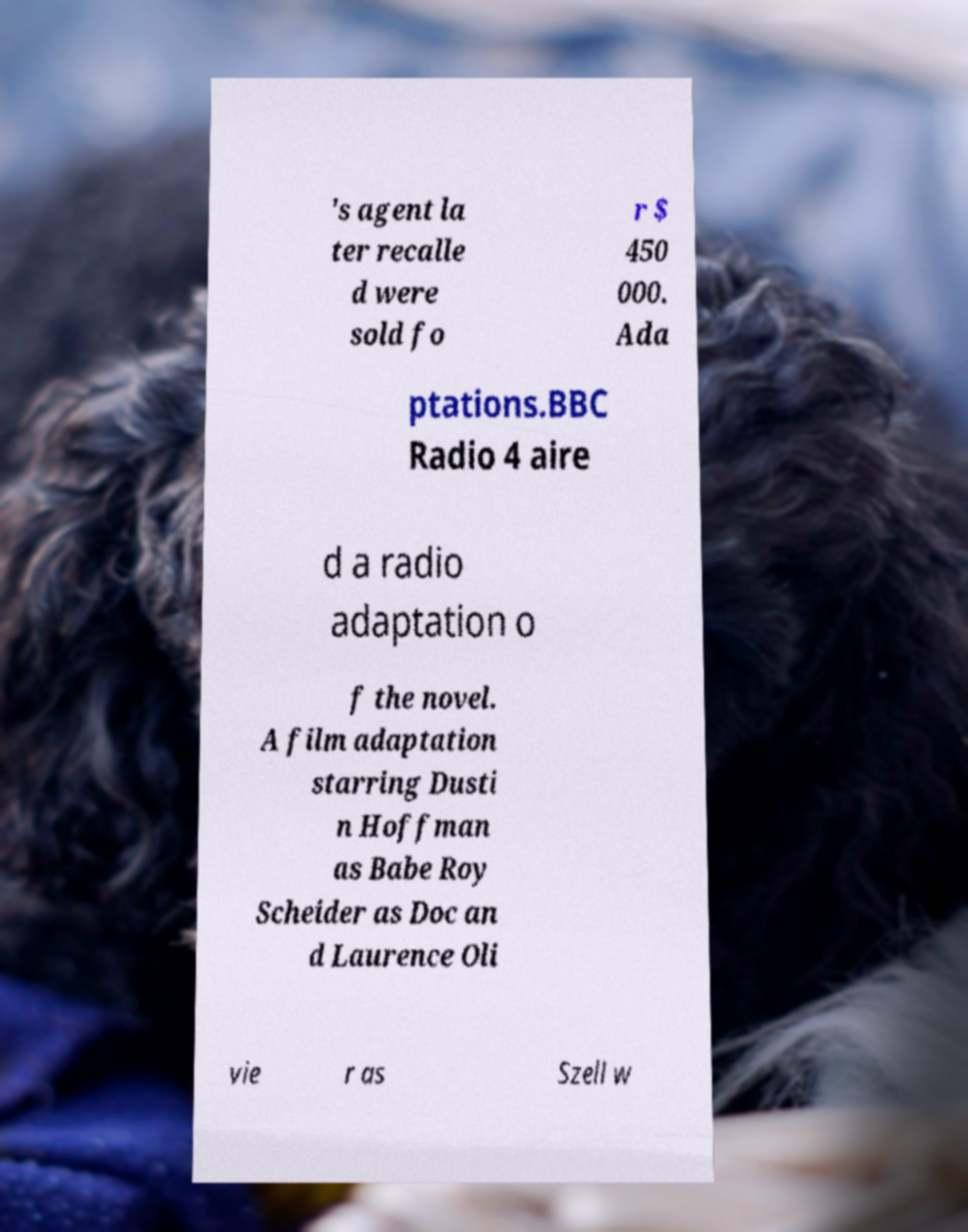I need the written content from this picture converted into text. Can you do that? 's agent la ter recalle d were sold fo r $ 450 000. Ada ptations.BBC Radio 4 aire d a radio adaptation o f the novel. A film adaptation starring Dusti n Hoffman as Babe Roy Scheider as Doc an d Laurence Oli vie r as Szell w 